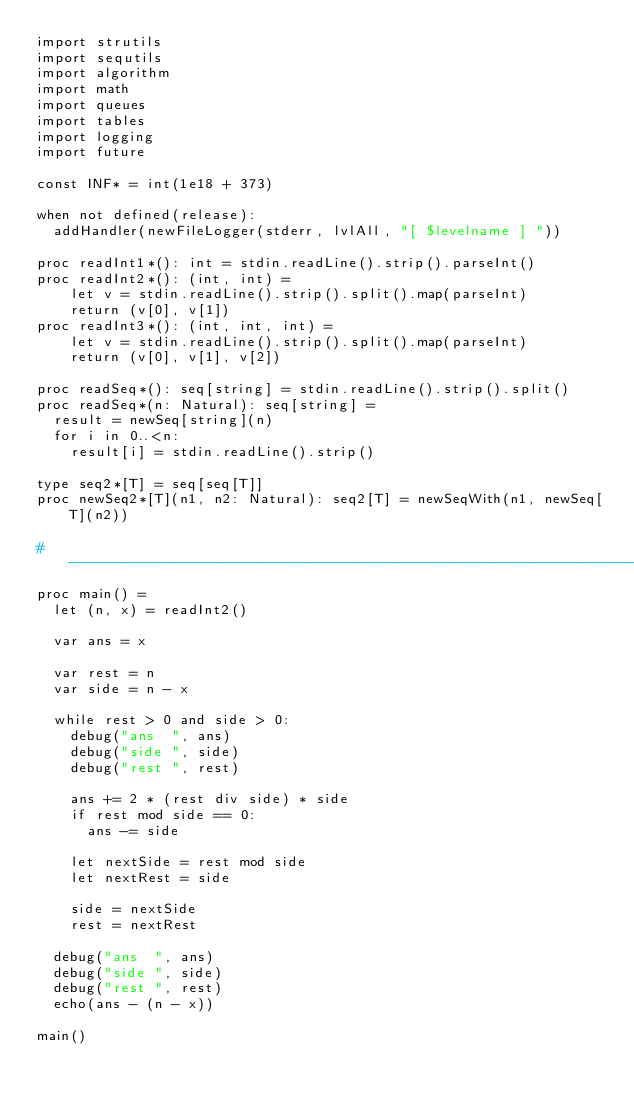Convert code to text. <code><loc_0><loc_0><loc_500><loc_500><_Nim_>import strutils
import sequtils
import algorithm
import math
import queues
import tables
import logging
import future

const INF* = int(1e18 + 373)

when not defined(release):
  addHandler(newFileLogger(stderr, lvlAll, "[ $levelname ] "))

proc readInt1*(): int = stdin.readLine().strip().parseInt()
proc readInt2*(): (int, int) =
    let v = stdin.readLine().strip().split().map(parseInt)
    return (v[0], v[1])
proc readInt3*(): (int, int, int) =
    let v = stdin.readLine().strip().split().map(parseInt)
    return (v[0], v[1], v[2])

proc readSeq*(): seq[string] = stdin.readLine().strip().split()
proc readSeq*(n: Natural): seq[string] =
  result = newSeq[string](n)
  for i in 0..<n:
    result[i] = stdin.readLine().strip()

type seq2*[T] = seq[seq[T]]
proc newSeq2*[T](n1, n2: Natural): seq2[T] = newSeqWith(n1, newSeq[T](n2))

#------------------------------------------------------------------------------#
proc main() =
  let (n, x) = readInt2()

  var ans = x

  var rest = n
  var side = n - x

  while rest > 0 and side > 0:
    debug("ans  ", ans)
    debug("side ", side)
    debug("rest ", rest)

    ans += 2 * (rest div side) * side
    if rest mod side == 0:
      ans -= side

    let nextSide = rest mod side
    let nextRest = side

    side = nextSide
    rest = nextRest

  debug("ans  ", ans)
  debug("side ", side)
  debug("rest ", rest)
  echo(ans - (n - x))

main()

</code> 